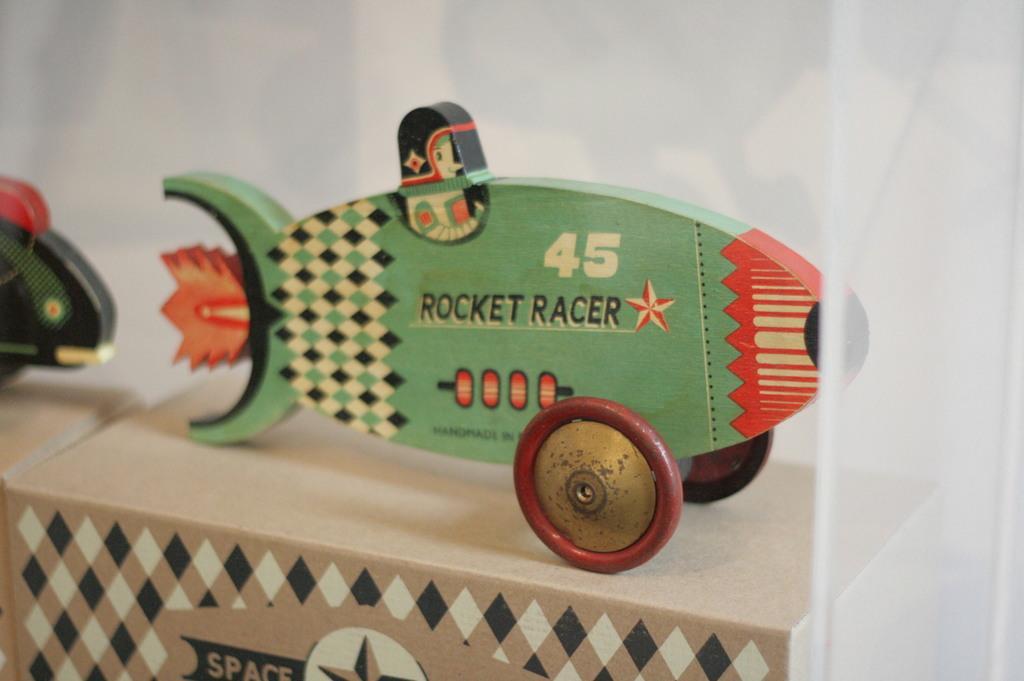Can you describe this image briefly? There is a toy rocket on which ''rocket racer'' is written. Its has 2 wheels. 